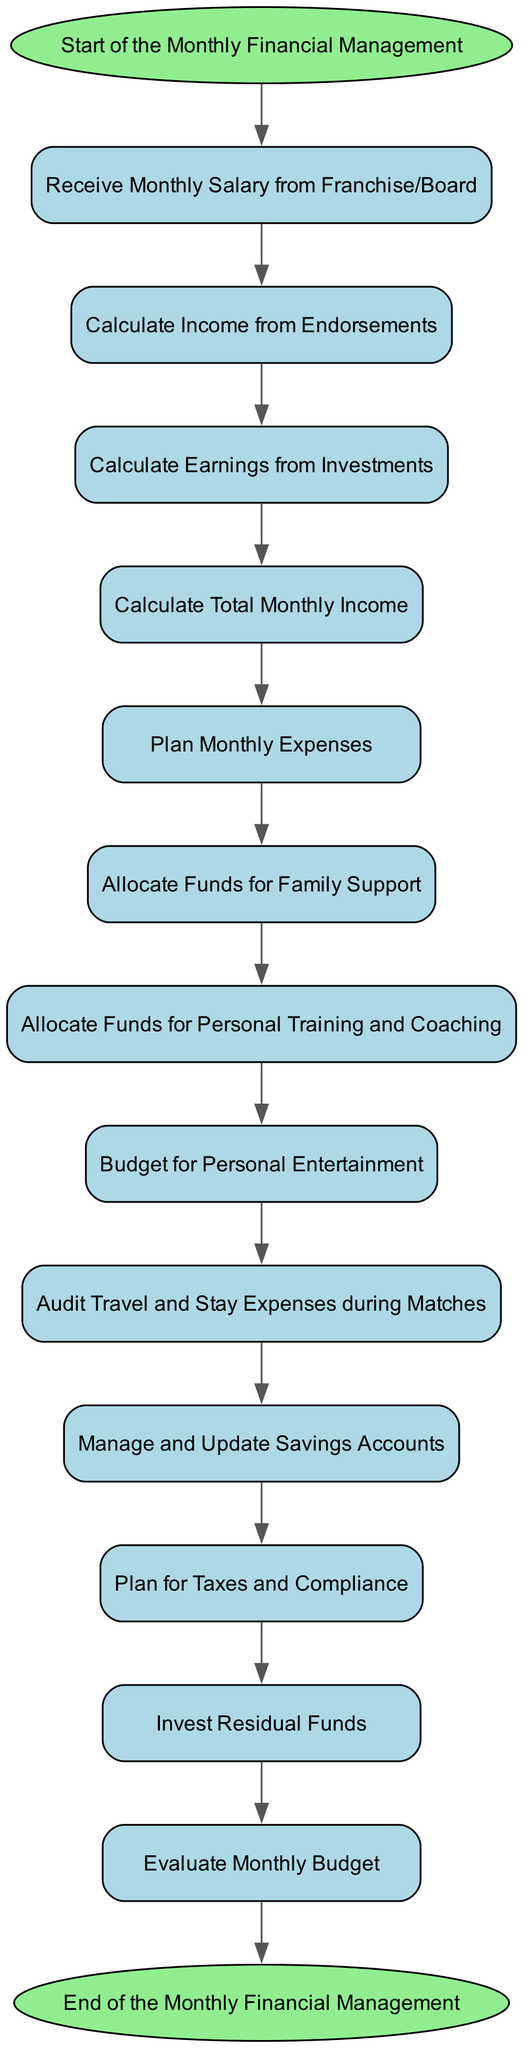What is the total number of activities in the diagram? The diagram lists activities starting from 'start' through to 'end'. There is a total of 14 activities that can be counted sequentially from the start point to the endpoint.
Answer: 14 What activity comes after "Budget for Personal Entertainment"? Following "Budget for Personal Entertainment", the diagram indicates that the next activity is "Audit Travel and Stay Expenses during Matches". This is derived directly from the transition in the flow of activities.
Answer: Audit Travel and Stay Expenses during Matches How many edges are there in the diagram? Each transition between activities represents an edge in the diagram. By analyzing the transitions provided, there are a total of 13 edges connecting the stated activities.
Answer: 13 What is the first activity listed in the diagram? The first activity in the diagram is denoted as the starting point, labeled as "Start of the Monthly Financial Management". It is the initial node in the flow, indicating the commencement of the process.
Answer: Start of the Monthly Financial Management Which activity directly follows "Plan Monthly Expenses"? The subsequent activity that directly follows "Plan Monthly Expenses" is "Allocate Funds for Family Support" based on the directed flow of the diagram. This outlines the structured progression from one activity to another.
Answer: Allocate Funds for Family Support What is the last activity before the end of the diagram? The last step in the activity flow occurring just before the end is "Evaluate Monthly Budget". This step is crucial as it leads to the conclusion of the financial management process.
Answer: Evaluate Monthly Budget How many nodes have 'Allocate' in their description? There are three nodes that contain the term 'Allocate' in their descriptions: "Allocate Funds for Family Support", "Allocate Funds for Personal Training and Coaching", and "Allocate Funds". This can be confirmed by examining each activity's description.
Answer: 3 What is the primary focus of the activity labeled "Tax Planning"? The "Tax Planning" activity is focused on the planning for taxes and compliance, indicated by its description in the diagram. This encapsulates the financial obligations related to taxation that need to be managed monthly.
Answer: Plan for Taxes and Compliance Which activity collects income from endorsements? The activity responsible for calculating income derived from endorsements is "Calculate Income from Endorsements". This reflects the importance of endorsement deals in the overall income structure for a professional cricketer.
Answer: Calculate Income from Endorsements 